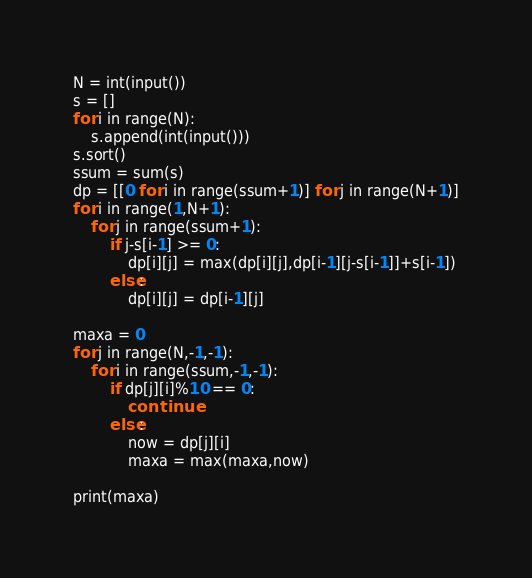<code> <loc_0><loc_0><loc_500><loc_500><_Python_>N = int(input())
s = []
for i in range(N):
    s.append(int(input()))
s.sort()
ssum = sum(s)
dp = [[0 for i in range(ssum+1)] for j in range(N+1)]
for i in range(1,N+1):
    for j in range(ssum+1):
        if j-s[i-1] >= 0:
            dp[i][j] = max(dp[i][j],dp[i-1][j-s[i-1]]+s[i-1])
        else:
            dp[i][j] = dp[i-1][j]

maxa = 0
for j in range(N,-1,-1):
    for i in range(ssum,-1,-1):
        if dp[j][i]%10 == 0:
            continue
        else:
            now = dp[j][i]
            maxa = max(maxa,now)

print(maxa)</code> 